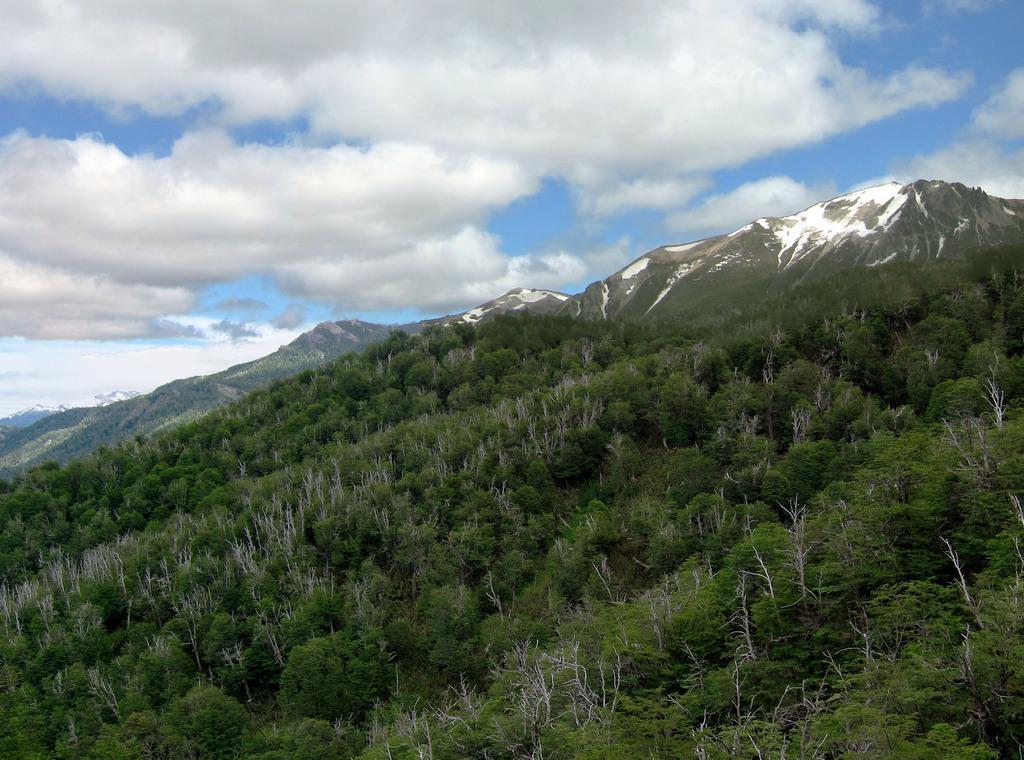Describe this image in one or two sentences. In this image I can see at the bottom there are trees. In the middle there are mountains with the snow, at the top it is the cloudy sky. 